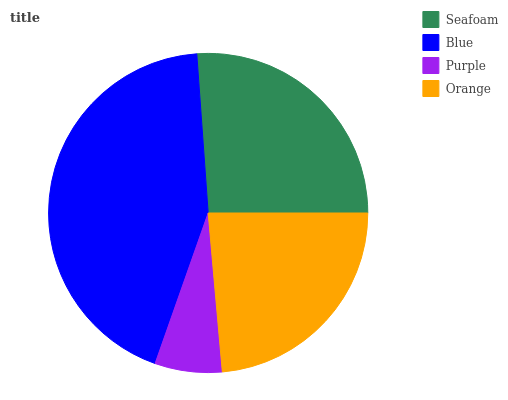Is Purple the minimum?
Answer yes or no. Yes. Is Blue the maximum?
Answer yes or no. Yes. Is Blue the minimum?
Answer yes or no. No. Is Purple the maximum?
Answer yes or no. No. Is Blue greater than Purple?
Answer yes or no. Yes. Is Purple less than Blue?
Answer yes or no. Yes. Is Purple greater than Blue?
Answer yes or no. No. Is Blue less than Purple?
Answer yes or no. No. Is Seafoam the high median?
Answer yes or no. Yes. Is Orange the low median?
Answer yes or no. Yes. Is Blue the high median?
Answer yes or no. No. Is Blue the low median?
Answer yes or no. No. 